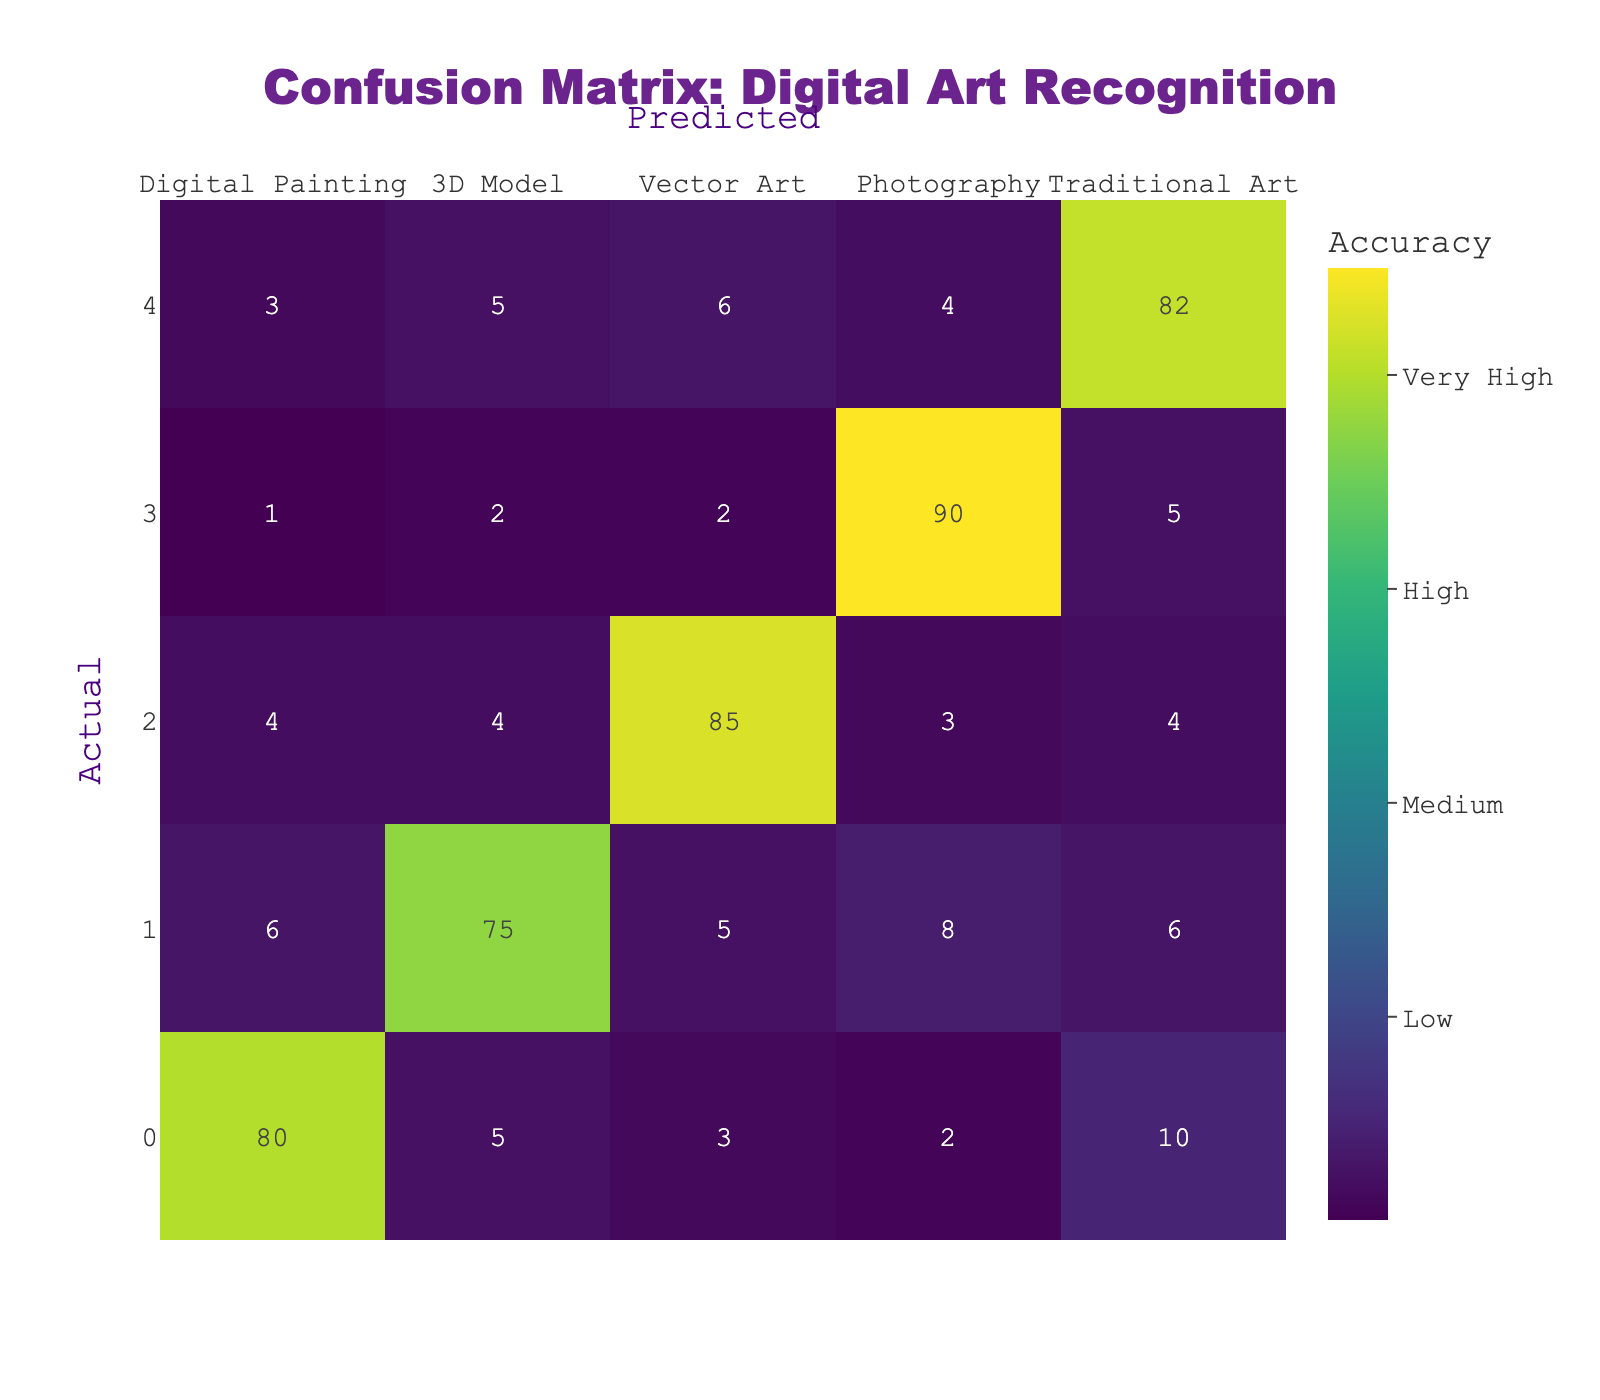What is the accuracy of predicting Digital Painting? According to the confusion matrix, the actual Digital Painting category correctly identified 80 times out of a total of 100 predictions tried in that category (80 + 5 + 3 + 2 + 10 = 100). Therefore, the accuracy is 80%.
Answer: 80% How many times was Photography incorrectly classified as Traditional Art? In the confusion matrix, the count of Photography that was predicted as Traditional Art is shown as 4. This means that 4 instances of Photography were mislabeled as Traditional Art.
Answer: 4 What is the total number of predictions for 3D Model? To find the total predictions for 3D Model, we add all the counts in the 3D Model row: 6 + 75 + 5 + 8 + 6 = 100. So the total predictions made for the 3D Model category is 100.
Answer: 100 Is Vector Art more accurately classified than Traditional Art? Vector Art has an accuracy of 85% (85 out of 100) while Traditional Art has an accuracy of 82% (82 out of 100). Since 85% is greater than 82%, it can be concluded that Vector Art is classified more accurately than Traditional Art.
Answer: Yes What is the difference in the number of times Digital Painting was predicted as 3D Model compared to it being predicted as Vector Art? Digital Painting was predicted as a 3D Model 5 times and as a Vector Art 3 times. The difference is 5 - 3 = 2.
Answer: 2 What percentage of the total predictions were correctly classified as Photography? To find the percentage, we take the number of correct predictions (90) and divide it by the total predictions (90 + 1 + 2 + 5 + 2 = 100). So, 90/100 = 0.90, which is 90%.
Answer: 90% How many instances of Traditional Art were misclassified as either Digital Painting or 3D Model? Traditional Art was misclassified as Digital Painting (3 instances) and as 3D Model (5 instances). Adding these together gives: 3 + 5 = 8 instances misclassified as either.
Answer: 8 What is the average number of misclassifications for each medium type? Each medium type has certain misclassifications: for Digital Painting (5 + 3 + 2 + 10 = 20), for 3D Model (6 + 5 + 8 + 6 = 25), for Vector Art (4 + 4 + 3 + 4 = 15), for Photography (1 + 2 + 2 + 5 = 10), and for Traditional Art (3 + 5 + 6 + 4 = 18). The total misclassifications are 20 + 25 + 15 + 10 + 18 = 98. The average is 98 / 5 = 19.6.
Answer: 19.6 